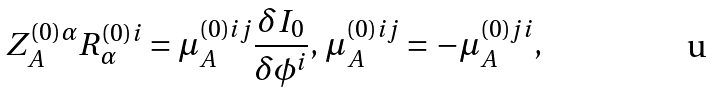Convert formula to latex. <formula><loc_0><loc_0><loc_500><loc_500>Z _ { A } ^ { ( 0 ) \alpha } R _ { \alpha } ^ { ( 0 ) i } = \mu _ { A } ^ { ( 0 ) i j } \frac { \delta I _ { 0 } } { \delta \phi ^ { i } } , \, \mu _ { A } ^ { ( 0 ) i j } = - \mu _ { A } ^ { ( 0 ) j i } ,</formula> 